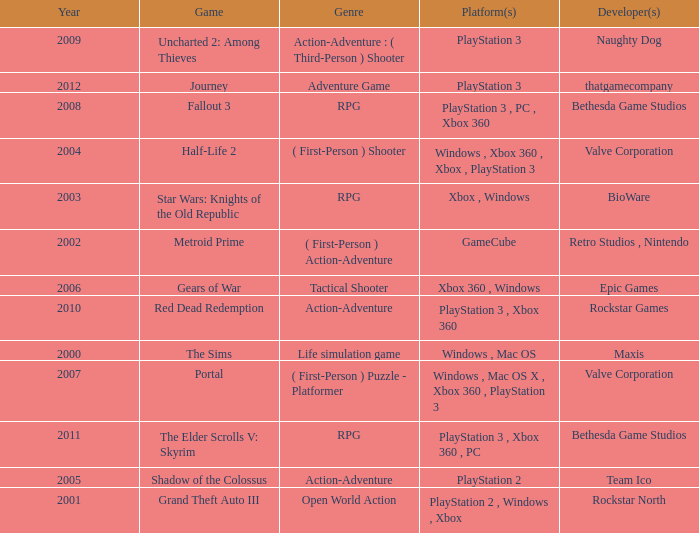What game was in 2005? Shadow of the Colossus. 